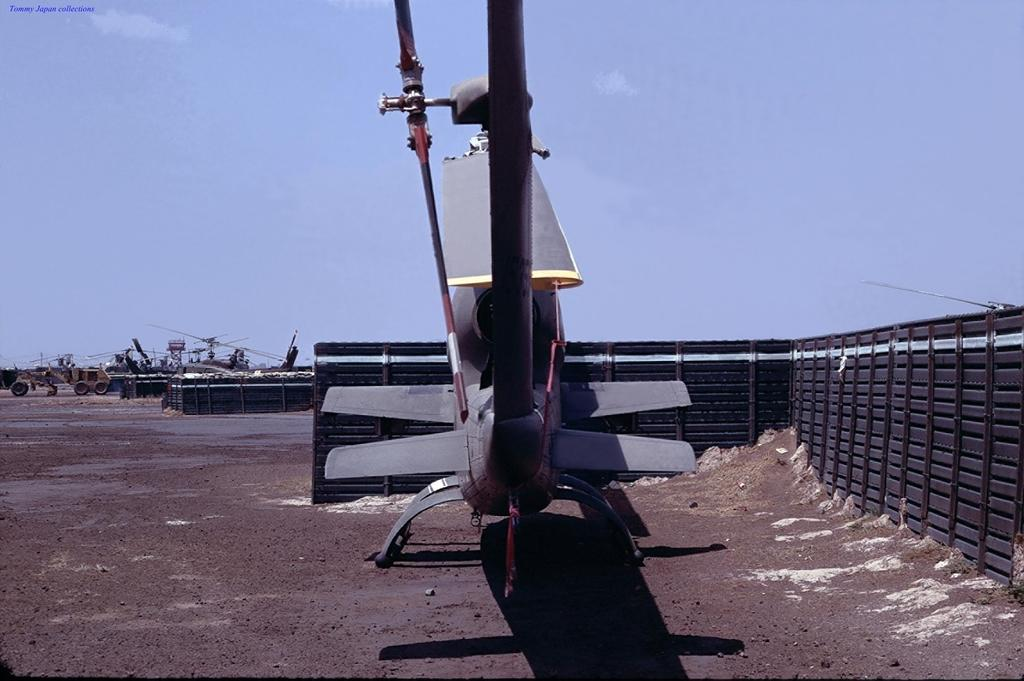What types of transportation are present in the image? There are vehicles in the image. Can you describe the helicopters in the image? The helicopters are on the ground in the image. What is located beside the vehicles in the image? There is a fence beside the vehicles in the image. What is present in the top left corner of the image? There is a watermark in the left top corner of the image. Where can the shop be found in the image? There is no shop present in the image. How many kittens are playing with the helicopters in the image? There are no kittens present in the image. 